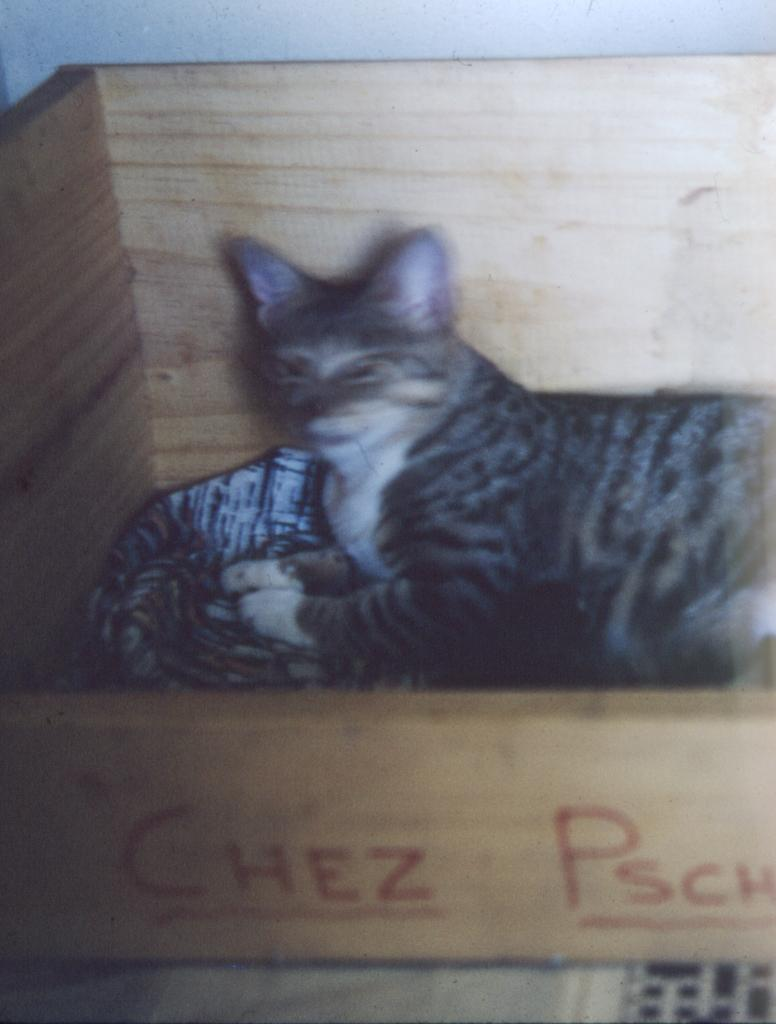What is the main subject of the image? The main subject of the image is a picture of a cat. Where is the cat located in the image? The cat is in a wooden box. What type of brain is visible in the image? There is no brain visible in the image; it features a picture of a cat in a wooden box. What rule is being enforced in the image? There is no rule being enforced in the image; it simply shows a cat in a wooden box. 